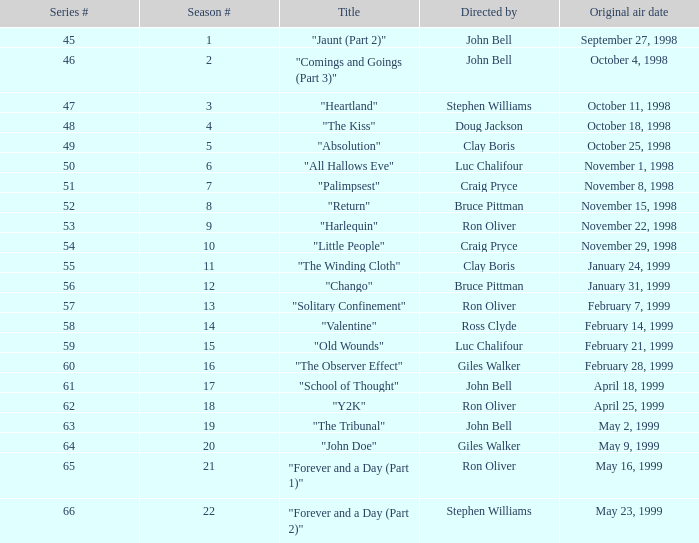Which first airing date possesses a season # under 21, and a title of "palimpsest"? November 8, 1998. 